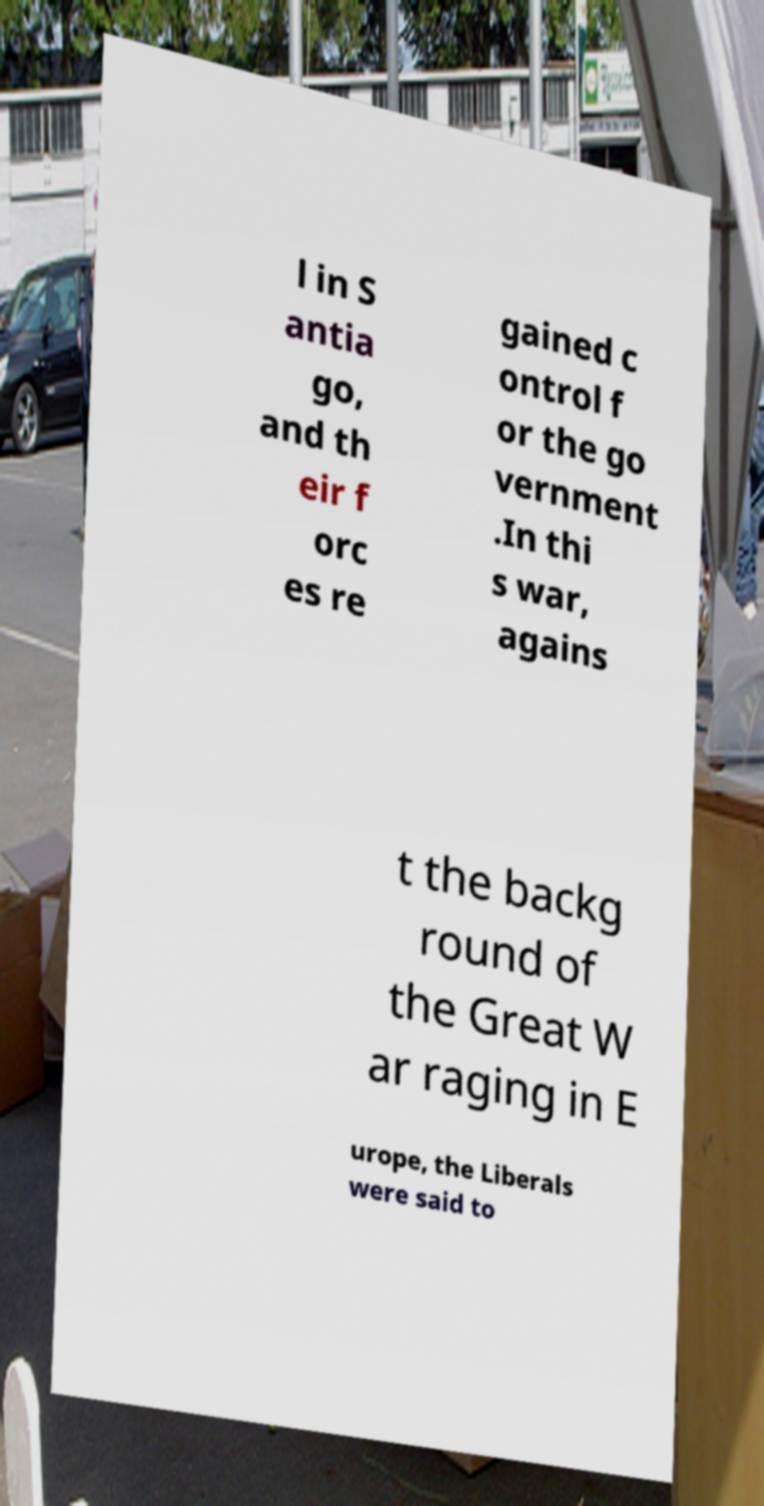What messages or text are displayed in this image? I need them in a readable, typed format. l in S antia go, and th eir f orc es re gained c ontrol f or the go vernment .In thi s war, agains t the backg round of the Great W ar raging in E urope, the Liberals were said to 